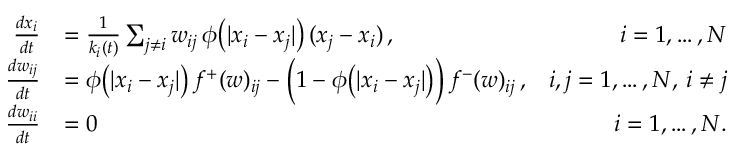<formula> <loc_0><loc_0><loc_500><loc_500>\begin{array} { r l r } { \frac { d x _ { i } } { d t } } & { = \frac { 1 } { k _ { i } ( t ) } \sum _ { j \neq i } w _ { i j } \, \phi \left ( | x _ { i } - x _ { j } | \right ) \, ( x _ { j } - x _ { i } ) \, , } & { i = 1 , \dots , N } \\ { \frac { d w _ { i j } } { d t } } & { = \phi \left ( | x _ { i } - x _ { j } | \right ) \, f ^ { + } ( w ) _ { i j } - \left ( 1 - \phi \left ( | x _ { i } - x _ { j } | \right ) \right ) \, f ^ { - } ( w ) _ { i j } \, , } & { i , j = 1 , \dots , N , \, i \neq j } \\ { \frac { d w _ { i i } } { d t } } & { = 0 } & { i = 1 , \dots , N . } \end{array}</formula> 